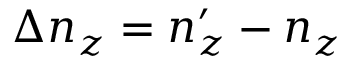<formula> <loc_0><loc_0><loc_500><loc_500>\Delta n _ { z } = n _ { z } ^ { \prime } - n _ { z }</formula> 